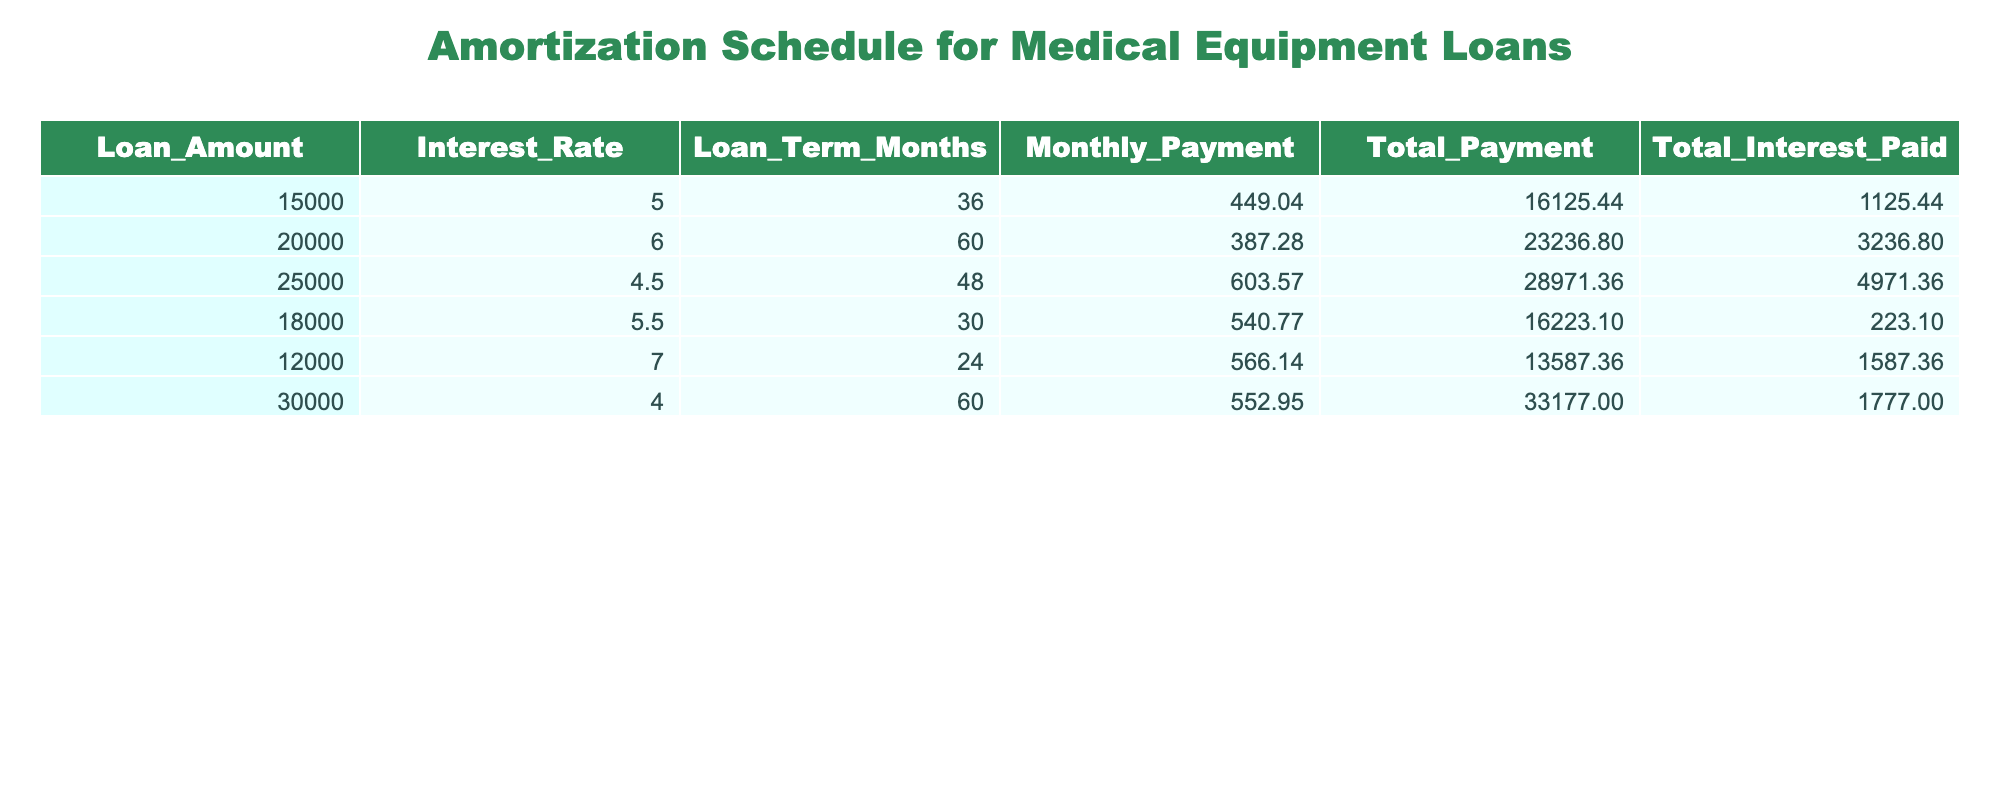What is the loan amount for the medical equipment with the longest term? The longest loan term in the table is 60 months, which corresponds to two loan amounts: 20000 and 30000. The loan amount for the medical equipment with the longest term is 20000 (6% interest rate loan).
Answer: 20000 What is the total interest paid for the loan amount of 15000? The total interest paid for the loan amount of 15000 is directly listed in the table as 1125.44.
Answer: 1125.44 How much is the total payment for the loan with the lowest interest rate? The loan with the lowest interest rate is the one for 25000 at 4.5%. The total payment for this loan is 28971.36, as stated in the table.
Answer: 28971.36 What is the average monthly payment across all loans? To find the average monthly payment, sum all the monthly payments (449.04 + 387.28 + 603.57 + 540.77 + 566.14 + 552.95 = 3099.85) and divide by the number of loans (6). Thus, the average monthly payment is 3099.85 / 6 = 516.64.
Answer: 516.64 Is the total payment for the 12000 loan higher than 14000? In the table, the total payment for the 12000 loan is 13587.36, which is lower than 14000. Therefore, the answer is no.
Answer: No What is the difference between the total payments for the highest and lowest loan amounts? The highest loan amount in the table is 30000, with a total payment of 33177.00, while the lowest loan amount is 12000, with a total payment of 13587.36. To find the difference, subtract: 33177.00 - 13587.36 = 19589.64.
Answer: 19589.64 Which loan has the highest total interest paid? The loan that has the highest total interest paid can be identified by comparing the total interest paid across all the loans. The highest total interest paid is for the 20000 loan, which is 3236.80.
Answer: 3236.80 What is the interest rate for the loan with the lowest monthly payment? The lowest monthly payment is 387.28 associated with a loan amount of 20000 (6% interest). This is identified by comparing the monthly payments for all loans in the table.
Answer: 6 How many loans have a total payment exceeding 20000? By examining the total payment column, the loans that exceed 20000 are the 20000 loan (total payment 23236.80), the 25000 loan (total payment 28971.36), and the 30000 loan (total payment 33177.00). This means there are three loans exceeding 20000.
Answer: 3 